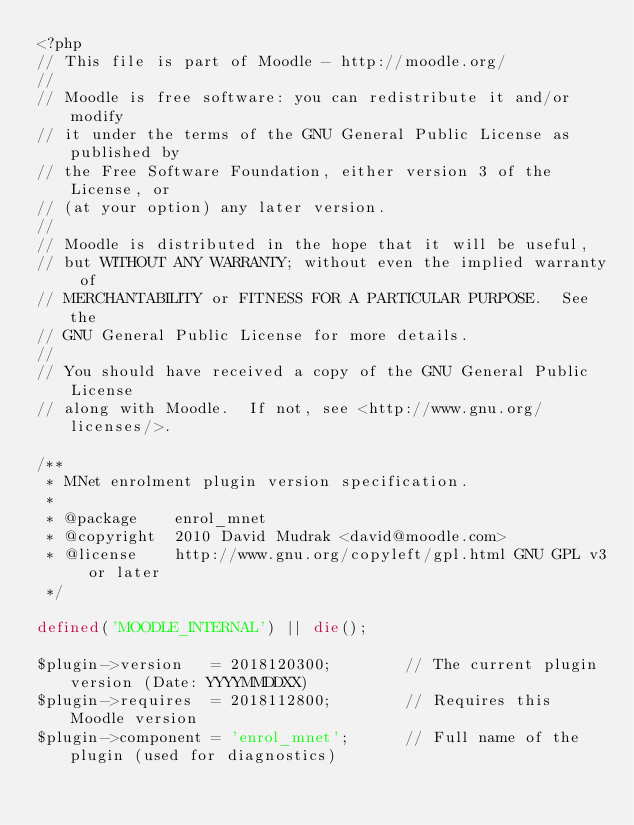Convert code to text. <code><loc_0><loc_0><loc_500><loc_500><_PHP_><?php
// This file is part of Moodle - http://moodle.org/
//
// Moodle is free software: you can redistribute it and/or modify
// it under the terms of the GNU General Public License as published by
// the Free Software Foundation, either version 3 of the License, or
// (at your option) any later version.
//
// Moodle is distributed in the hope that it will be useful,
// but WITHOUT ANY WARRANTY; without even the implied warranty of
// MERCHANTABILITY or FITNESS FOR A PARTICULAR PURPOSE.  See the
// GNU General Public License for more details.
//
// You should have received a copy of the GNU General Public License
// along with Moodle.  If not, see <http://www.gnu.org/licenses/>.

/**
 * MNet enrolment plugin version specification.
 *
 * @package    enrol_mnet
 * @copyright  2010 David Mudrak <david@moodle.com>
 * @license    http://www.gnu.org/copyleft/gpl.html GNU GPL v3 or later
 */

defined('MOODLE_INTERNAL') || die();

$plugin->version   = 2018120300;        // The current plugin version (Date: YYYYMMDDXX)
$plugin->requires  = 2018112800;        // Requires this Moodle version
$plugin->component = 'enrol_mnet';      // Full name of the plugin (used for diagnostics)
</code> 